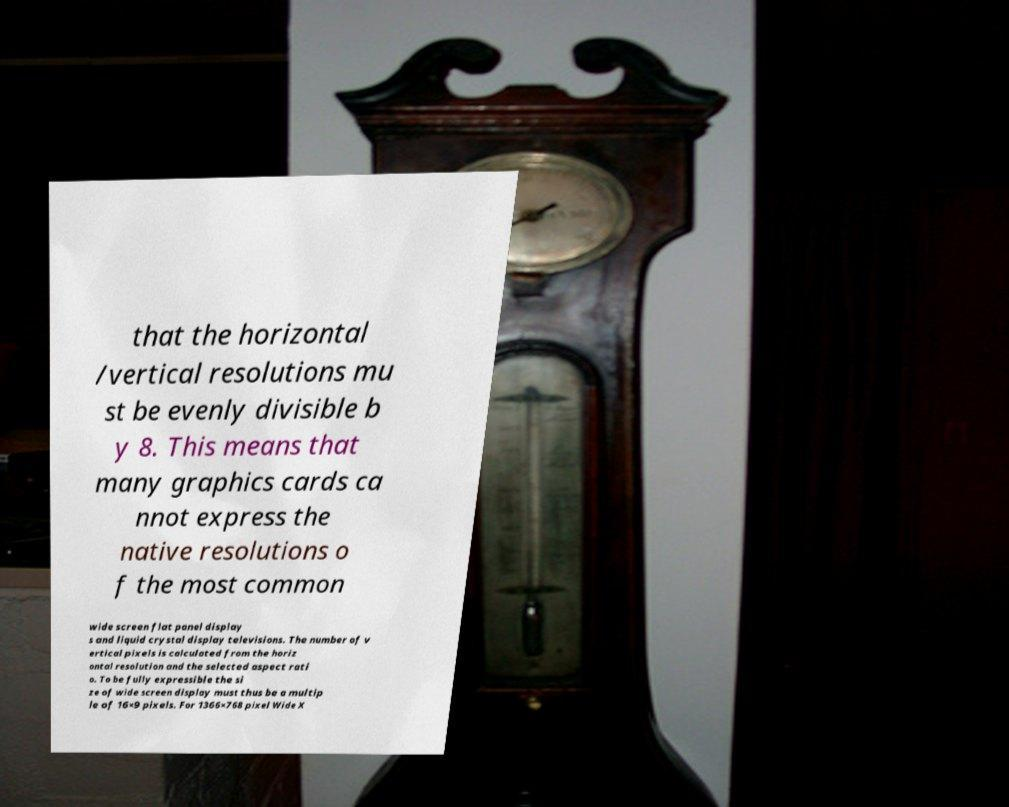I need the written content from this picture converted into text. Can you do that? that the horizontal /vertical resolutions mu st be evenly divisible b y 8. This means that many graphics cards ca nnot express the native resolutions o f the most common wide screen flat panel display s and liquid crystal display televisions. The number of v ertical pixels is calculated from the horiz ontal resolution and the selected aspect rati o. To be fully expressible the si ze of wide screen display must thus be a multip le of 16×9 pixels. For 1366×768 pixel Wide X 